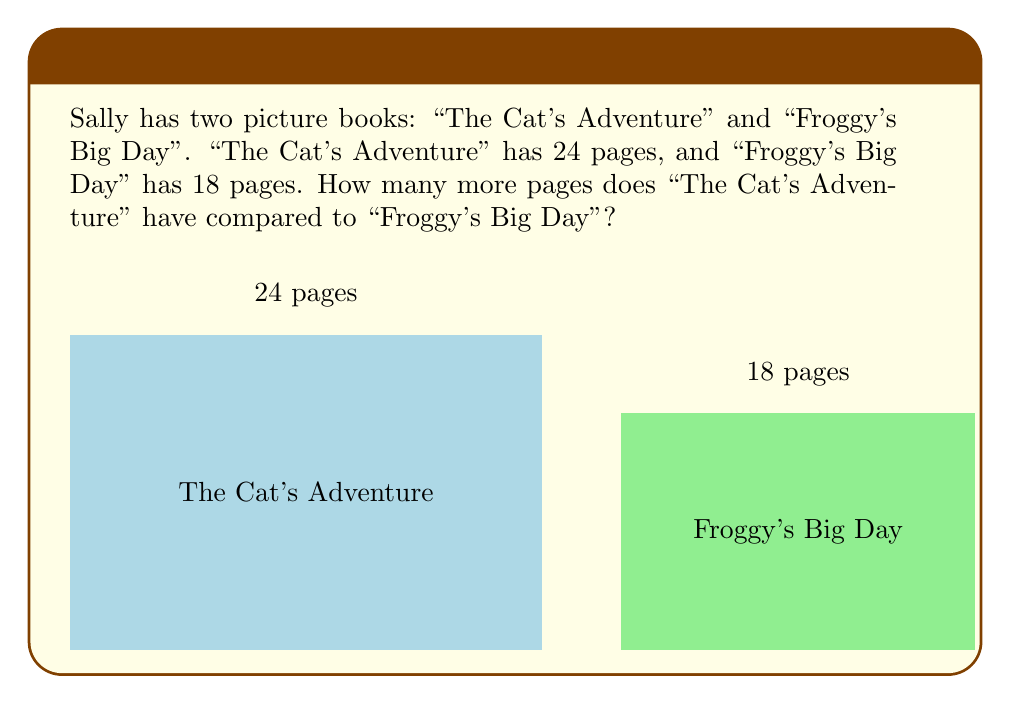Give your solution to this math problem. Let's solve this step-by-step:

1. First, we need to identify the number of pages in each book:
   - "The Cat's Adventure" has 24 pages
   - "Froggy's Big Day" has 18 pages

2. To find out how many more pages "The Cat's Adventure" has, we need to subtract the number of pages in "Froggy's Big Day" from "The Cat's Adventure":

   $$ 24 - 18 = 6 $$

3. We can check our answer by adding the difference back to the smaller number:
   $$ 18 + 6 = 24 $$

   This confirms that our calculation is correct.

So, "The Cat's Adventure" has 6 more pages than "Froggy's Big Day".
Answer: 6 pages 